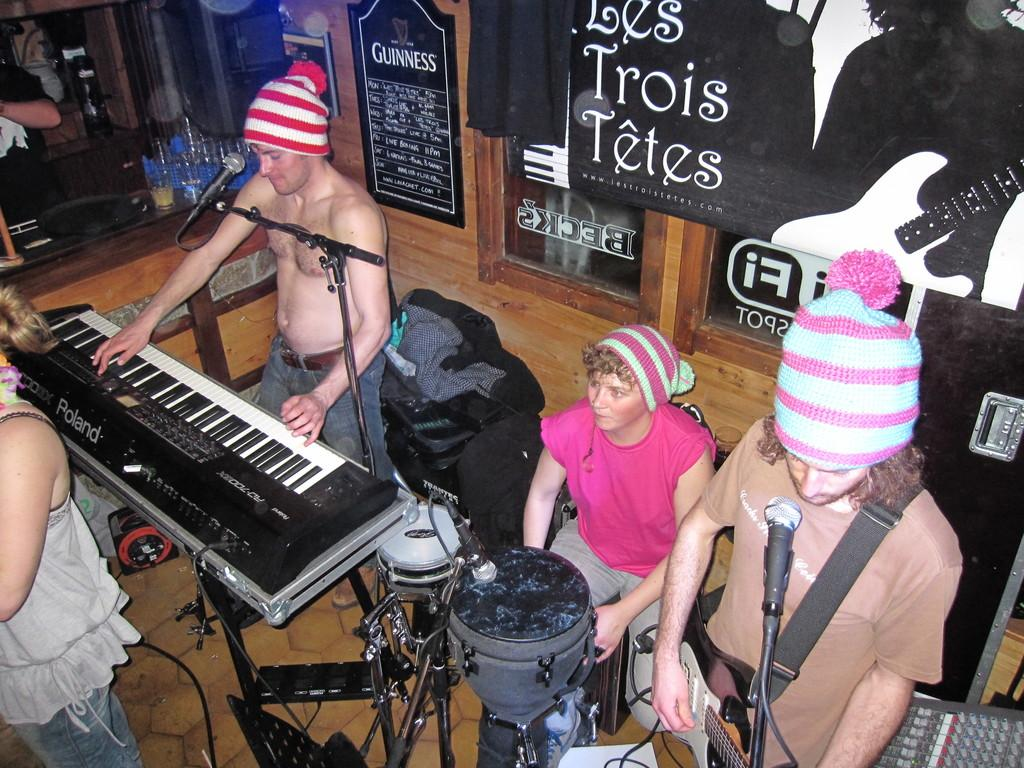What are the persons in the image doing? The persons in the image are playing musical instruments. What can be seen in the background of the image? There is a door and a black color sheet in the background of the image. What type of rings can be seen on the persons' fingers in the image? There is no mention of rings or any jewelry on the persons' fingers in the image. How many bombs are visible in the image? There are no bombs present in the image. 